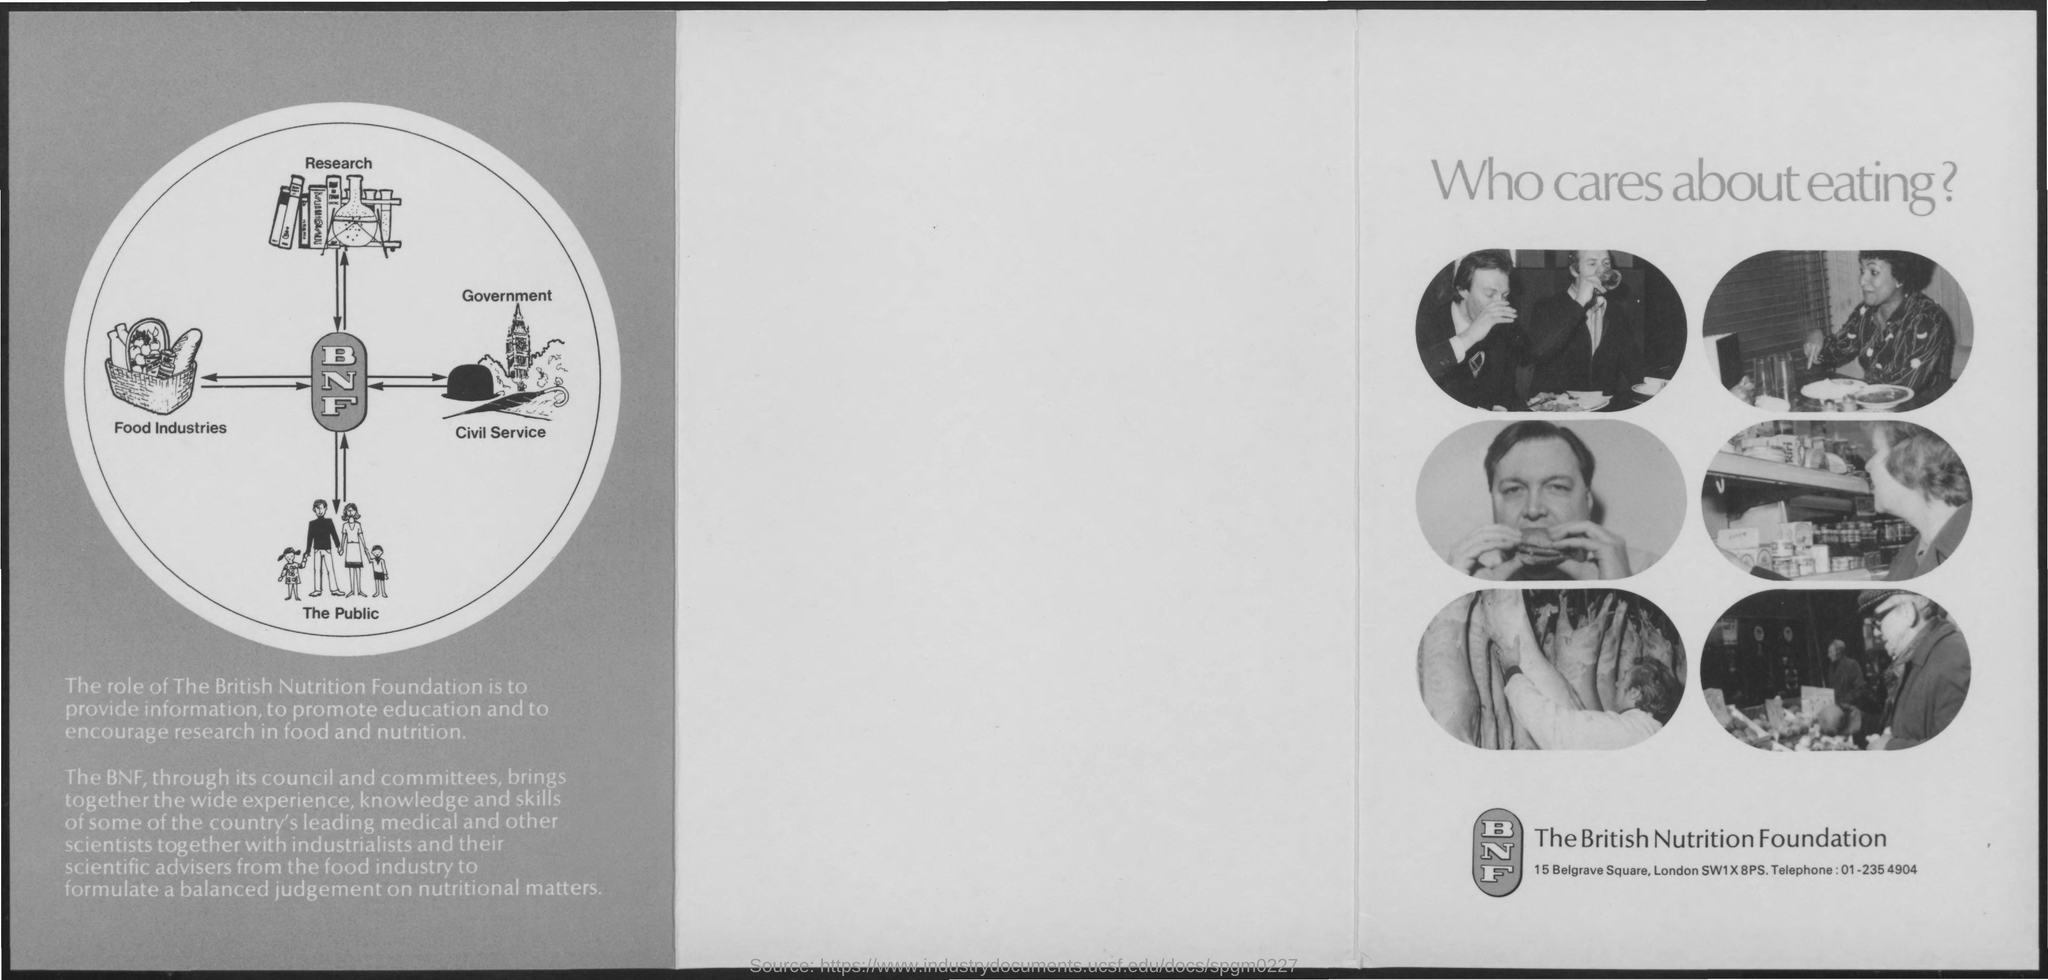Who brings together the wide experience?
Your answer should be compact. The British Nutrition Foundation. What is the Telephone for the British Nutrition Foundation?
Keep it short and to the point. 01-235 4904. 